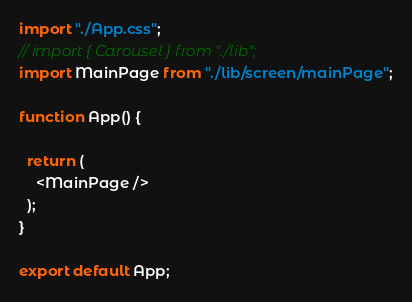Convert code to text. <code><loc_0><loc_0><loc_500><loc_500><_JavaScript_>import "./App.css";
// import { Carousel } from "./lib";
import MainPage from "./lib/screen/mainPage";

function App() {

  return (
    <MainPage />
  );
}

export default App;
</code> 